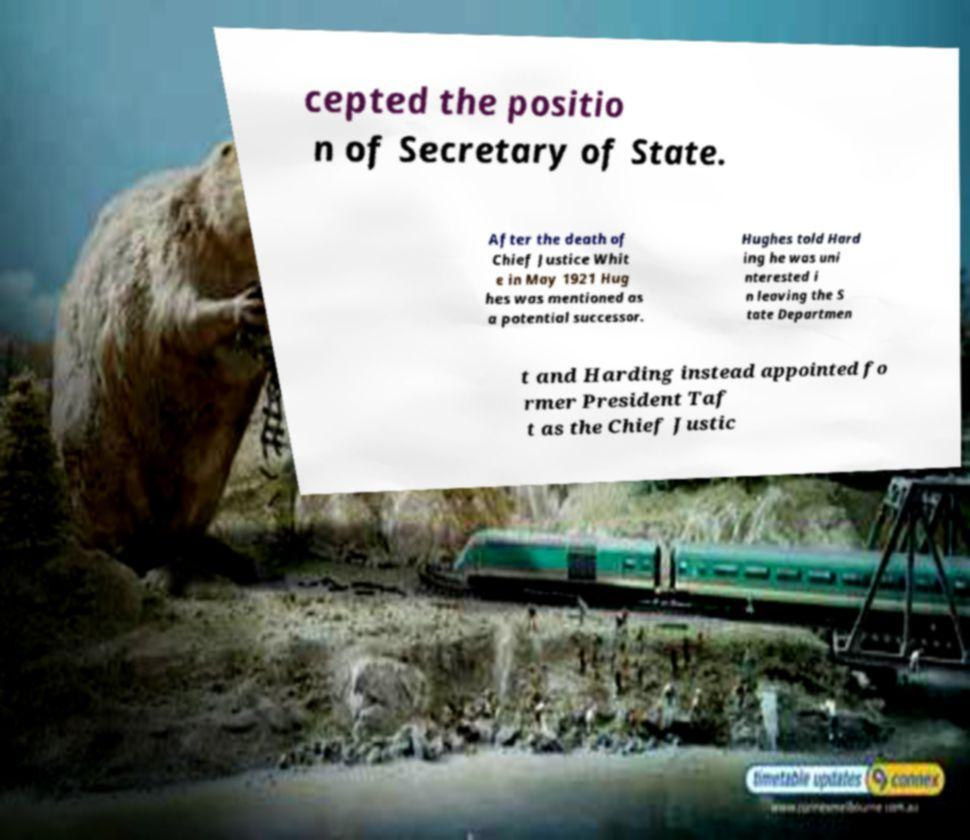Can you accurately transcribe the text from the provided image for me? cepted the positio n of Secretary of State. After the death of Chief Justice Whit e in May 1921 Hug hes was mentioned as a potential successor. Hughes told Hard ing he was uni nterested i n leaving the S tate Departmen t and Harding instead appointed fo rmer President Taf t as the Chief Justic 